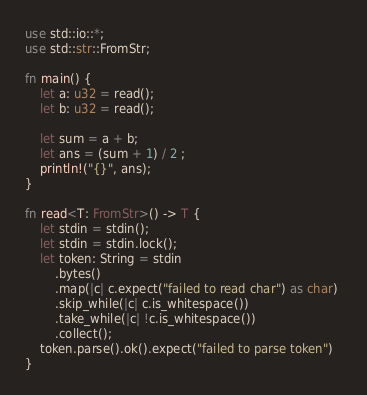<code> <loc_0><loc_0><loc_500><loc_500><_Rust_>use std::io::*;
use std::str::FromStr;

fn main() {
    let a: u32 = read();
    let b: u32 = read();

    let sum = a + b;
    let ans = (sum + 1) / 2 ;
    println!("{}", ans);
}

fn read<T: FromStr>() -> T {
    let stdin = stdin();
    let stdin = stdin.lock();
    let token: String = stdin
        .bytes()
        .map(|c| c.expect("failed to read char") as char) 
        .skip_while(|c| c.is_whitespace())
        .take_while(|c| !c.is_whitespace())
        .collect();
    token.parse().ok().expect("failed to parse token")
}
</code> 